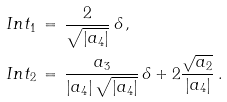<formula> <loc_0><loc_0><loc_500><loc_500>& I n t _ { 1 } \, = \, \frac { 2 } { \sqrt { | a _ { 4 } | } } \, \delta \, , \\ & I n t _ { 2 } \, = \, \frac { a _ { 3 } } { | a _ { 4 } | \, \sqrt { | a _ { 4 } | } } \, \delta + 2 \frac { \sqrt { a _ { 2 } } } { | a _ { 4 } | } \, .</formula> 